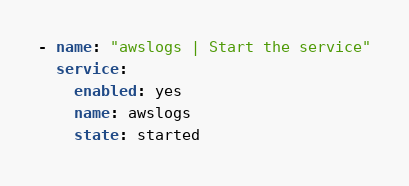Convert code to text. <code><loc_0><loc_0><loc_500><loc_500><_YAML_>- name: "awslogs | Start the service"
  service:
    enabled: yes
    name: awslogs
    state: started
</code> 